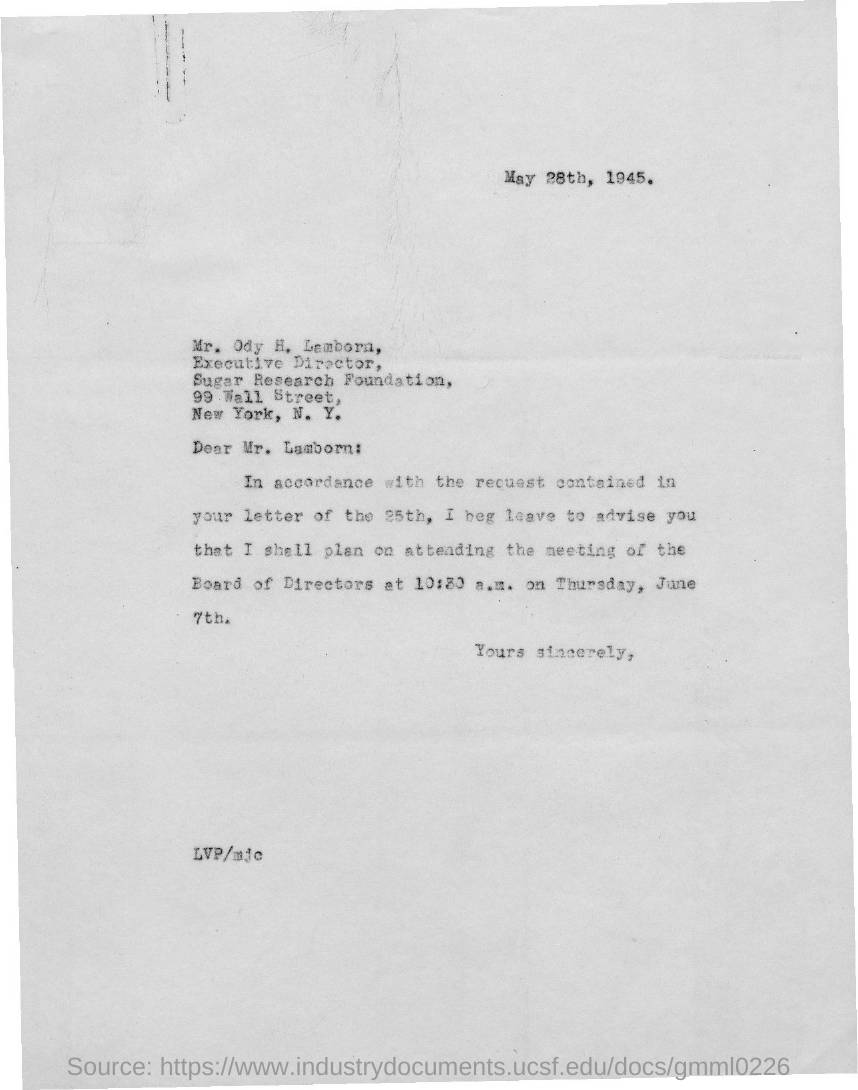What is the date on the document?
Your answer should be compact. May 28th, 1945. To Whom is this letter addressed to?
Your response must be concise. Mr. Ody H. Lamborn. 